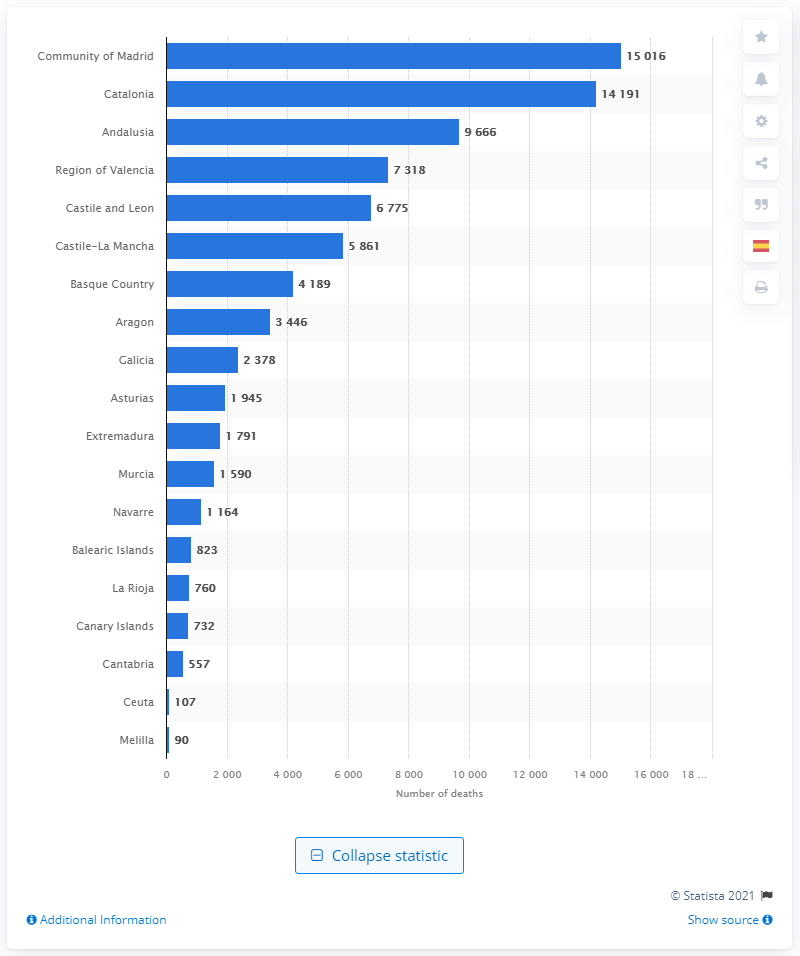Mention a couple of crucial points in this snapshot. There have been 1,5016 confirmed deaths as a result of complications from coronavirus. 